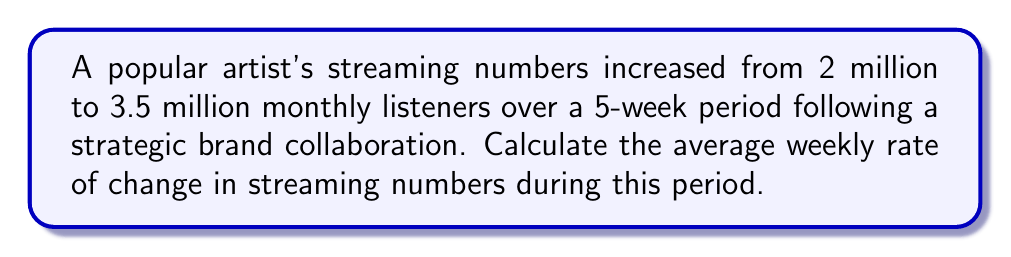Could you help me with this problem? To find the average weekly rate of change, we need to follow these steps:

1. Calculate the total change in streaming numbers:
   $\text{Total change} = \text{Final value} - \text{Initial value}$
   $\text{Total change} = 3.5 \text{ million} - 2 \text{ million} = 1.5 \text{ million}$

2. Determine the time period:
   The change occurred over a 5-week period.

3. Calculate the average weekly rate of change:
   $$\text{Rate of change} = \frac{\text{Total change}}{\text{Time period}}$$
   $$\text{Rate of change} = \frac{1.5 \text{ million}}{5 \text{ weeks}}$$
   $$\text{Rate of change} = 0.3 \text{ million per week}$$

4. Convert to a more readable format:
   $0.3 \text{ million} = 300,000$

Therefore, the average weekly rate of change in streaming numbers is 300,000 listeners per week.
Answer: 300,000 listeners/week 